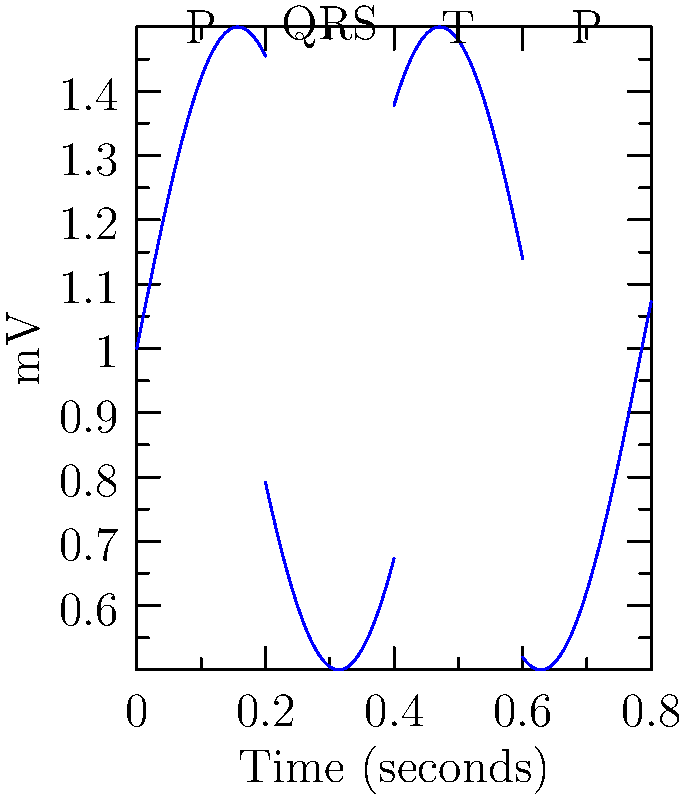Based on the ECG waveform shown, which of the following heart rhythms does this pattern most likely represent?

A) Atrial fibrillation
B) Sinus bradycardia
C) Normal sinus rhythm
D) Ventricular tachycardia To interpret this ECG waveform and determine the correct heart rhythm, let's analyze it step-by-step:

1. Regularity: The waveform shows a regular pattern with consistent intervals between each complex.

2. P waves: Clear P waves are visible before each QRS complex. They are rounded and uniform in shape.

3. PR interval: The PR interval (between the start of the P wave and the start of the QRS complex) appears consistent and within normal limits.

4. QRS complex: The QRS complexes are narrow and uniform in shape, indicating normal ventricular depolarization.

5. T waves: T waves are visible following each QRS complex, representing normal ventricular repolarization.

6. Rate: While we can't determine the exact heart rate from this short segment, the rhythm appears to be at a normal rate (between 60-100 beats per minute).

These characteristics are consistent with a normal sinus rhythm:
- Regular rhythm
- Normal P waves preceding each QRS complex
- Normal PR interval
- Normal QRS complexes
- Normal T waves

The other options can be ruled out:
A) Atrial fibrillation would show irregular rhythm and absence of P waves.
B) Sinus bradycardia would show a rate slower than 60 beats per minute.
D) Ventricular tachycardia would show wide, bizarre QRS complexes at a rapid rate without visible P waves.

Therefore, the ECG waveform most likely represents a normal sinus rhythm.
Answer: Normal sinus rhythm 